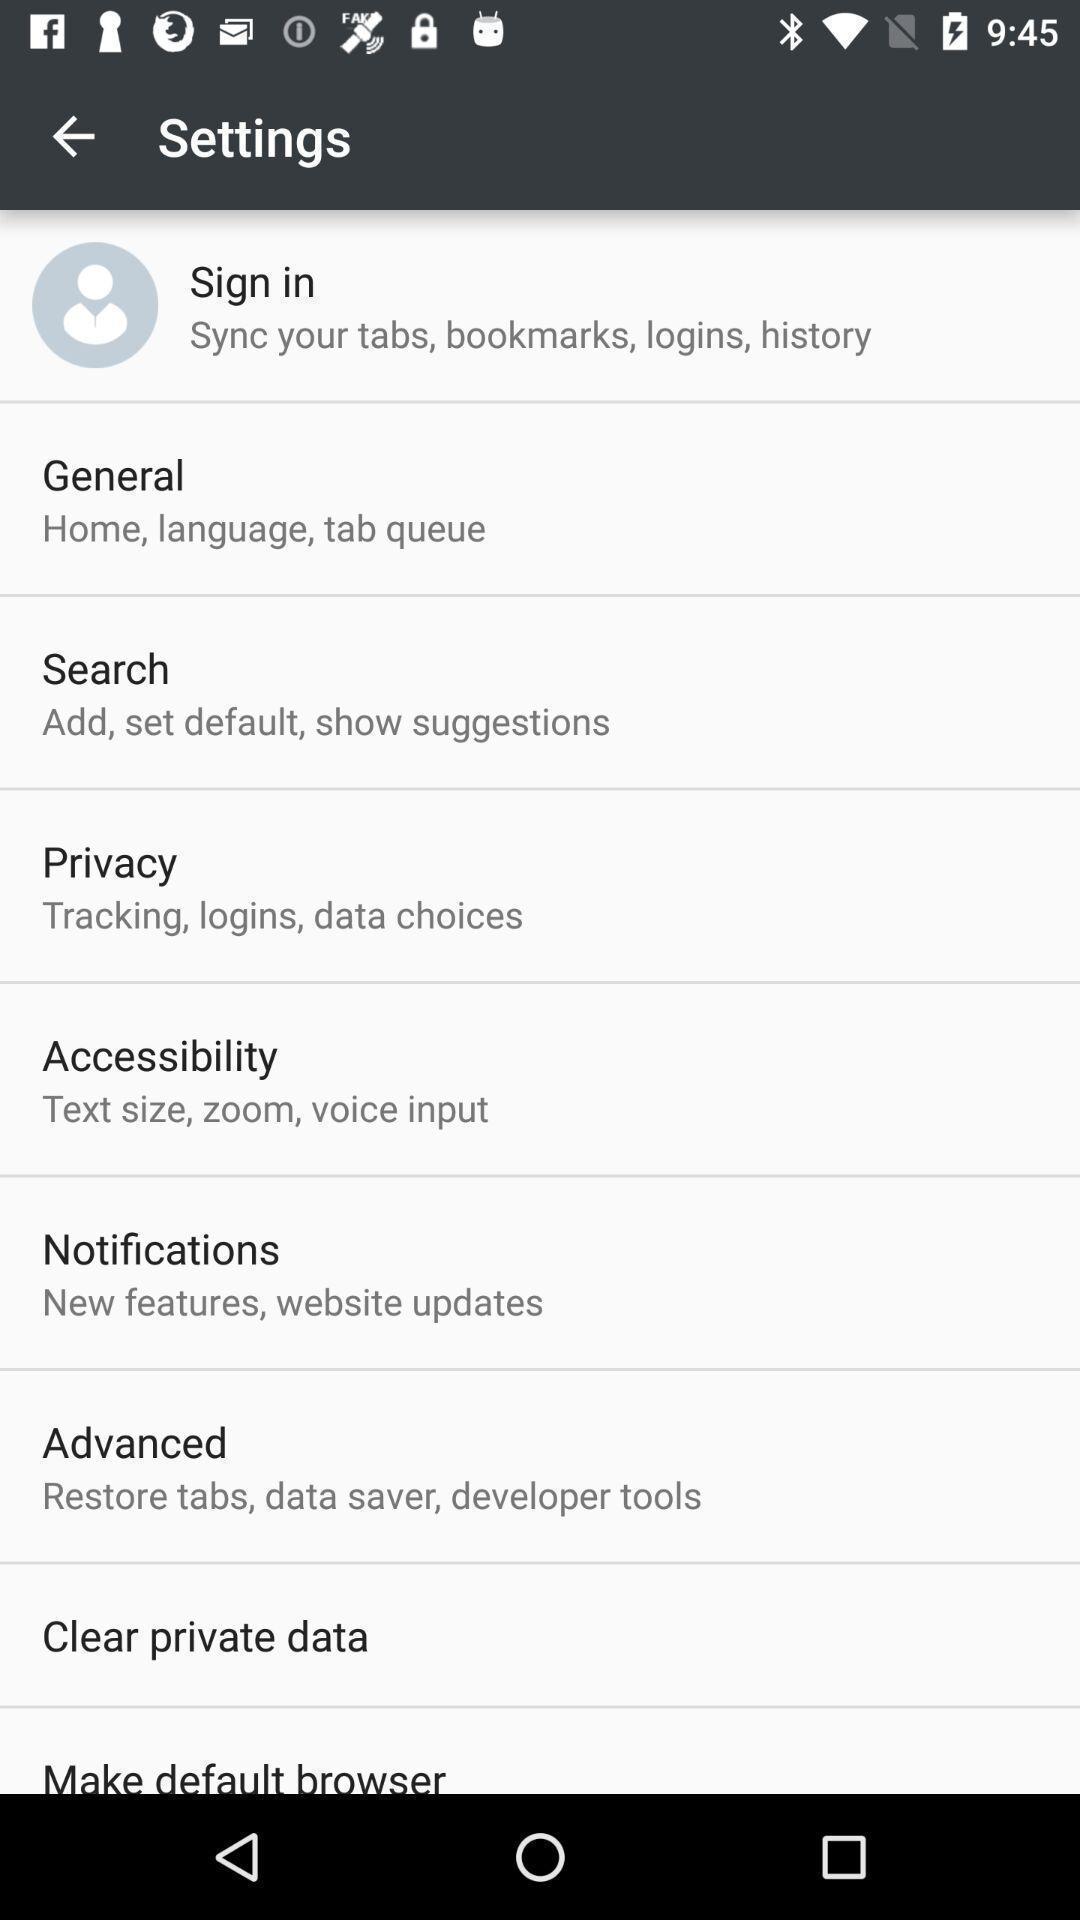Describe the content in this image. Page displaying various settings. 